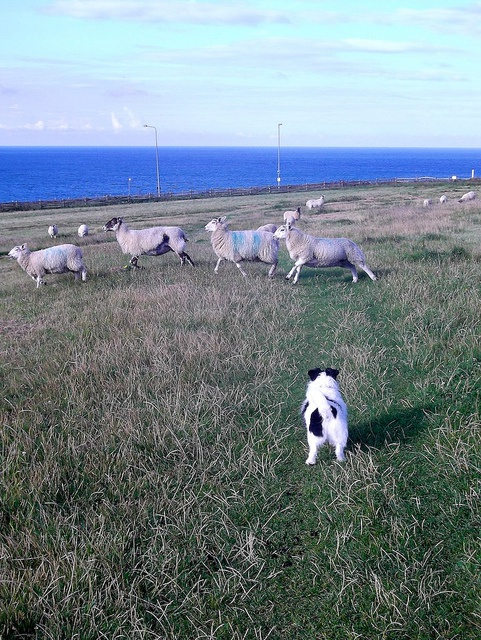Describe the objects in this image and their specific colors. I can see dog in lightblue, lavender, black, and gray tones, sheep in lightblue, darkgray, lavender, and gray tones, sheep in lightblue, darkgray, lavender, and gray tones, sheep in lightblue, darkgray, and lavender tones, and sheep in lightblue, lavender, and darkgray tones in this image. 